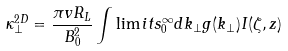<formula> <loc_0><loc_0><loc_500><loc_500>\kappa _ { \perp } ^ { 2 D } = \frac { \pi v R _ { L } } { B _ { 0 } ^ { 2 } } \int \lim i t s _ { 0 } ^ { \infty } d k _ { \perp } g ( k _ { \perp } ) I ( \zeta , z )</formula> 